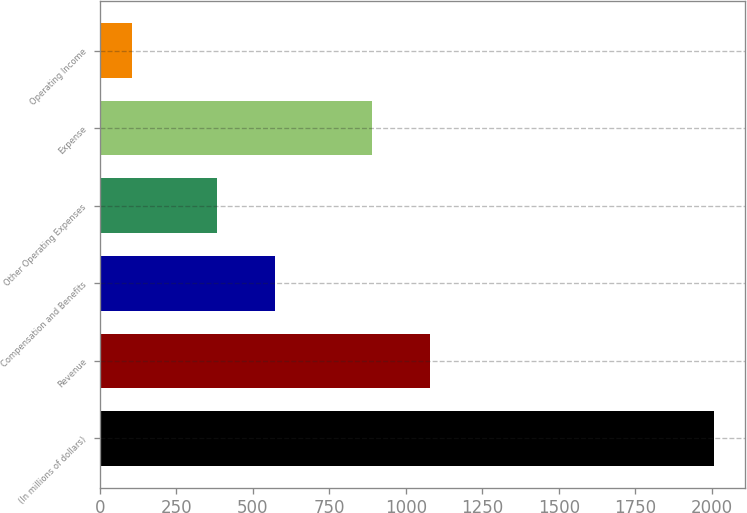Convert chart to OTSL. <chart><loc_0><loc_0><loc_500><loc_500><bar_chart><fcel>(In millions of dollars)<fcel>Revenue<fcel>Compensation and Benefits<fcel>Other Operating Expenses<fcel>Expense<fcel>Operating Income<nl><fcel>2007<fcel>1079.1<fcel>573.1<fcel>383<fcel>889<fcel>106<nl></chart> 